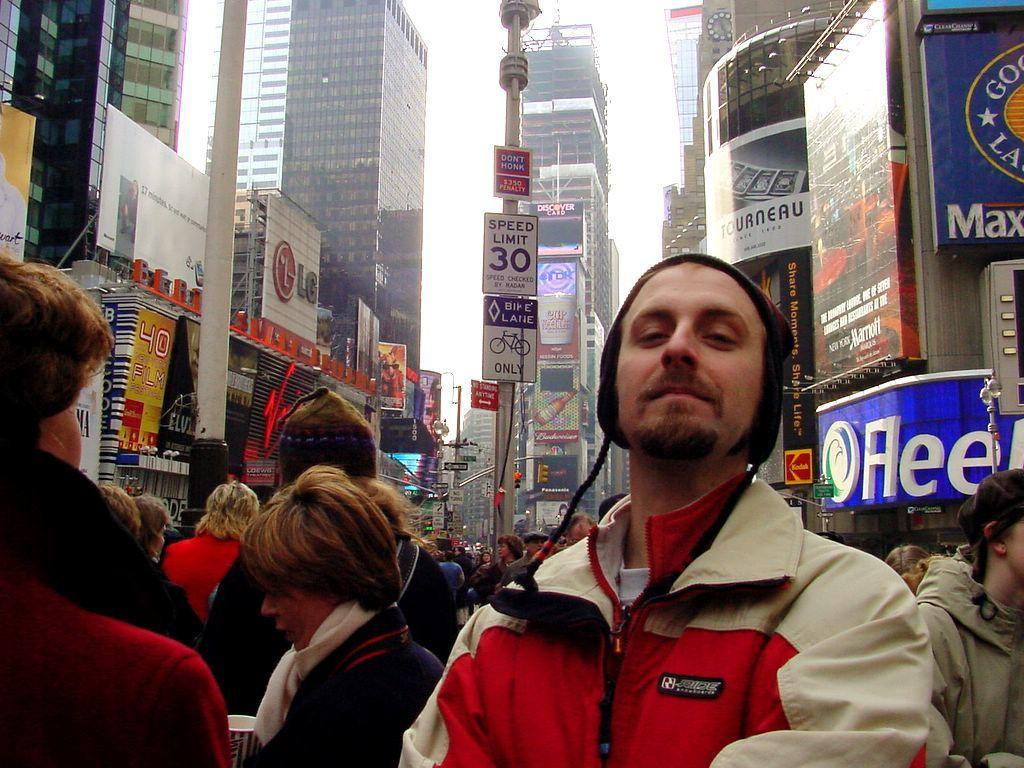<image>
Describe the image concisely. a man standing in a crowd behind a pole with a 'speed limit 30' sign on it 